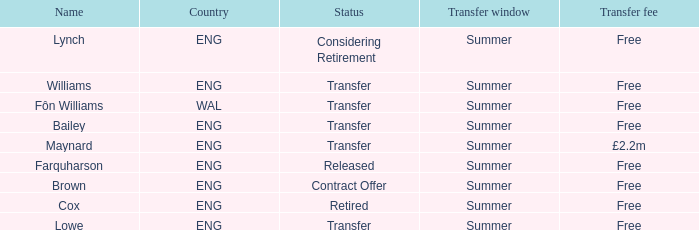What is the transfer period with a status of transfer from the wal nation? Summer. Would you mind parsing the complete table? {'header': ['Name', 'Country', 'Status', 'Transfer window', 'Transfer fee'], 'rows': [['Lynch', 'ENG', 'Considering Retirement', 'Summer', 'Free'], ['Williams', 'ENG', 'Transfer', 'Summer', 'Free'], ['Fôn Williams', 'WAL', 'Transfer', 'Summer', 'Free'], ['Bailey', 'ENG', 'Transfer', 'Summer', 'Free'], ['Maynard', 'ENG', 'Transfer', 'Summer', '£2.2m'], ['Farquharson', 'ENG', 'Released', 'Summer', 'Free'], ['Brown', 'ENG', 'Contract Offer', 'Summer', 'Free'], ['Cox', 'ENG', 'Retired', 'Summer', 'Free'], ['Lowe', 'ENG', 'Transfer', 'Summer', 'Free']]} 